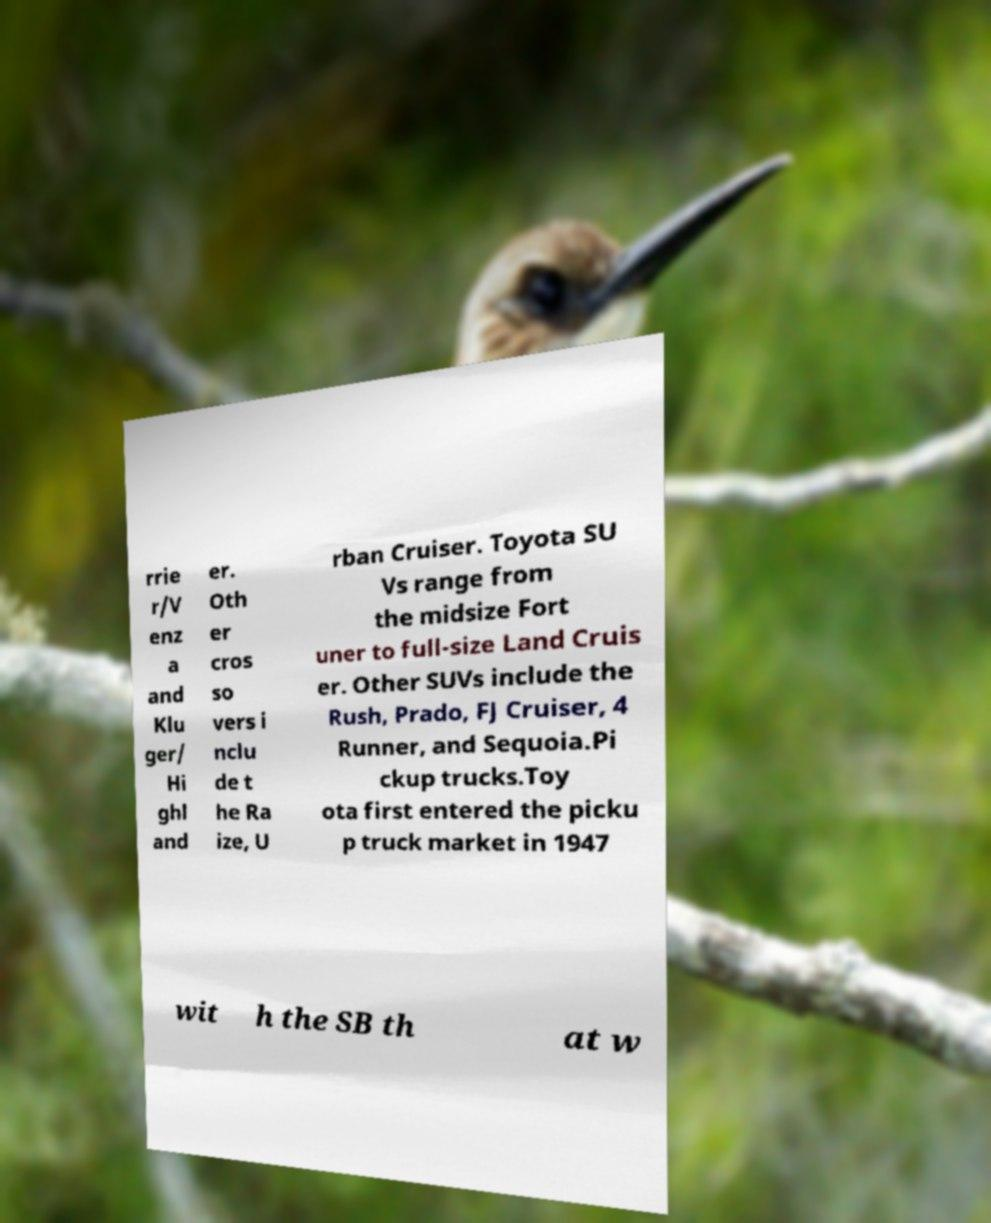Could you assist in decoding the text presented in this image and type it out clearly? rrie r/V enz a and Klu ger/ Hi ghl and er. Oth er cros so vers i nclu de t he Ra ize, U rban Cruiser. Toyota SU Vs range from the midsize Fort uner to full-size Land Cruis er. Other SUVs include the Rush, Prado, FJ Cruiser, 4 Runner, and Sequoia.Pi ckup trucks.Toy ota first entered the picku p truck market in 1947 wit h the SB th at w 